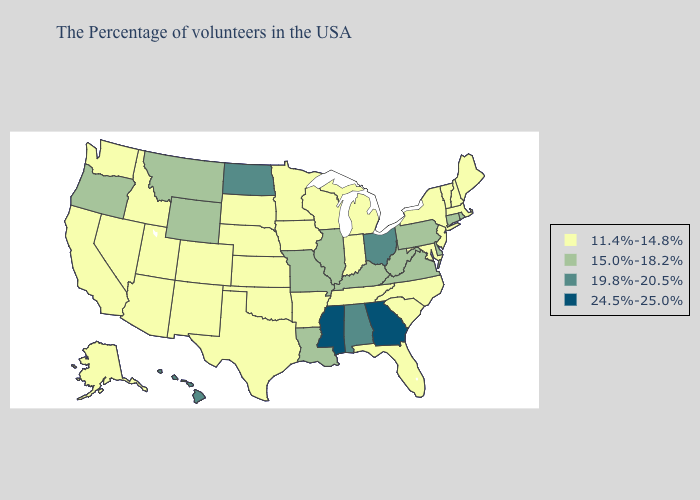What is the lowest value in the USA?
Be succinct. 11.4%-14.8%. Does the first symbol in the legend represent the smallest category?
Short answer required. Yes. Among the states that border Delaware , does Pennsylvania have the lowest value?
Answer briefly. No. Among the states that border Kansas , does Missouri have the lowest value?
Keep it brief. No. Name the states that have a value in the range 19.8%-20.5%?
Answer briefly. Ohio, Alabama, North Dakota, Hawaii. Does Delaware have the highest value in the South?
Keep it brief. No. Among the states that border South Carolina , does North Carolina have the highest value?
Write a very short answer. No. What is the value of Wyoming?
Give a very brief answer. 15.0%-18.2%. What is the lowest value in states that border Kentucky?
Short answer required. 11.4%-14.8%. What is the value of South Carolina?
Give a very brief answer. 11.4%-14.8%. What is the lowest value in the West?
Write a very short answer. 11.4%-14.8%. Does Wyoming have the highest value in the West?
Keep it brief. No. What is the value of Nebraska?
Answer briefly. 11.4%-14.8%. What is the lowest value in the South?
Give a very brief answer. 11.4%-14.8%. What is the value of Indiana?
Keep it brief. 11.4%-14.8%. 